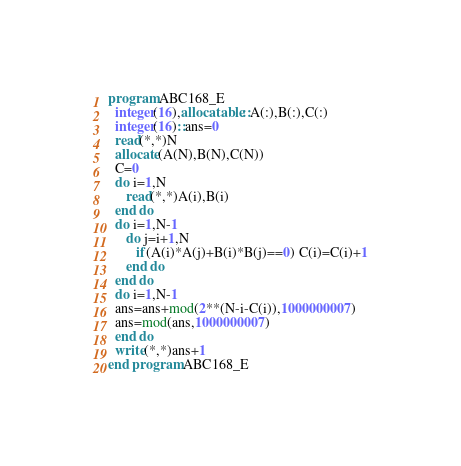<code> <loc_0><loc_0><loc_500><loc_500><_FORTRAN_>program ABC168_E
  integer(16),allocatable::A(:),B(:),C(:)
  integer(16)::ans=0
  read(*,*)N
  allocate(A(N),B(N),C(N))
  C=0
  do i=1,N
     read(*,*)A(i),B(i)
  end do
  do i=1,N-1
     do j=i+1,N
        if(A(i)*A(j)+B(i)*B(j)==0) C(i)=C(i)+1
     end do
  end do
  do i=1,N-1
  ans=ans+mod(2**(N-i-C(i)),1000000007)
  ans=mod(ans,1000000007)
  end do
  write(*,*)ans+1
end program ABC168_E</code> 